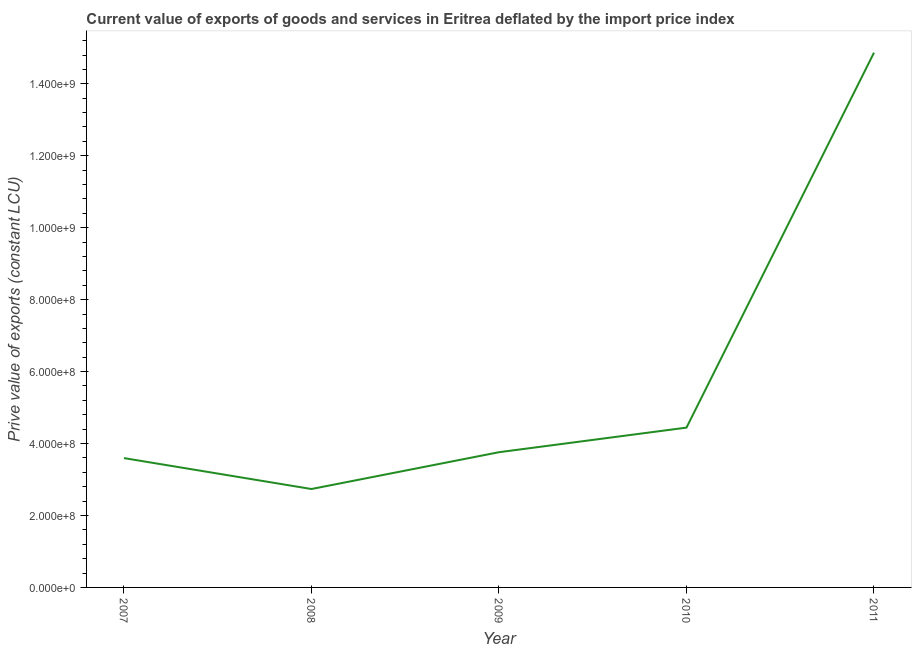What is the price value of exports in 2010?
Offer a terse response. 4.44e+08. Across all years, what is the maximum price value of exports?
Offer a terse response. 1.49e+09. Across all years, what is the minimum price value of exports?
Your answer should be very brief. 2.74e+08. What is the sum of the price value of exports?
Ensure brevity in your answer.  2.94e+09. What is the difference between the price value of exports in 2007 and 2008?
Give a very brief answer. 8.60e+07. What is the average price value of exports per year?
Your response must be concise. 5.88e+08. What is the median price value of exports?
Offer a very short reply. 3.76e+08. What is the ratio of the price value of exports in 2007 to that in 2010?
Provide a succinct answer. 0.81. Is the difference between the price value of exports in 2007 and 2008 greater than the difference between any two years?
Your answer should be compact. No. What is the difference between the highest and the second highest price value of exports?
Give a very brief answer. 1.04e+09. What is the difference between the highest and the lowest price value of exports?
Make the answer very short. 1.21e+09. In how many years, is the price value of exports greater than the average price value of exports taken over all years?
Keep it short and to the point. 1. How many lines are there?
Provide a short and direct response. 1. Are the values on the major ticks of Y-axis written in scientific E-notation?
Provide a short and direct response. Yes. Does the graph contain any zero values?
Offer a very short reply. No. What is the title of the graph?
Offer a very short reply. Current value of exports of goods and services in Eritrea deflated by the import price index. What is the label or title of the X-axis?
Offer a very short reply. Year. What is the label or title of the Y-axis?
Provide a short and direct response. Prive value of exports (constant LCU). What is the Prive value of exports (constant LCU) in 2007?
Offer a terse response. 3.60e+08. What is the Prive value of exports (constant LCU) of 2008?
Offer a very short reply. 2.74e+08. What is the Prive value of exports (constant LCU) in 2009?
Make the answer very short. 3.76e+08. What is the Prive value of exports (constant LCU) of 2010?
Give a very brief answer. 4.44e+08. What is the Prive value of exports (constant LCU) of 2011?
Make the answer very short. 1.49e+09. What is the difference between the Prive value of exports (constant LCU) in 2007 and 2008?
Provide a short and direct response. 8.60e+07. What is the difference between the Prive value of exports (constant LCU) in 2007 and 2009?
Ensure brevity in your answer.  -1.63e+07. What is the difference between the Prive value of exports (constant LCU) in 2007 and 2010?
Provide a succinct answer. -8.47e+07. What is the difference between the Prive value of exports (constant LCU) in 2007 and 2011?
Give a very brief answer. -1.13e+09. What is the difference between the Prive value of exports (constant LCU) in 2008 and 2009?
Keep it short and to the point. -1.02e+08. What is the difference between the Prive value of exports (constant LCU) in 2008 and 2010?
Your answer should be compact. -1.71e+08. What is the difference between the Prive value of exports (constant LCU) in 2008 and 2011?
Keep it short and to the point. -1.21e+09. What is the difference between the Prive value of exports (constant LCU) in 2009 and 2010?
Provide a short and direct response. -6.84e+07. What is the difference between the Prive value of exports (constant LCU) in 2009 and 2011?
Ensure brevity in your answer.  -1.11e+09. What is the difference between the Prive value of exports (constant LCU) in 2010 and 2011?
Make the answer very short. -1.04e+09. What is the ratio of the Prive value of exports (constant LCU) in 2007 to that in 2008?
Your answer should be compact. 1.31. What is the ratio of the Prive value of exports (constant LCU) in 2007 to that in 2010?
Offer a terse response. 0.81. What is the ratio of the Prive value of exports (constant LCU) in 2007 to that in 2011?
Offer a very short reply. 0.24. What is the ratio of the Prive value of exports (constant LCU) in 2008 to that in 2009?
Offer a terse response. 0.73. What is the ratio of the Prive value of exports (constant LCU) in 2008 to that in 2010?
Provide a short and direct response. 0.62. What is the ratio of the Prive value of exports (constant LCU) in 2008 to that in 2011?
Make the answer very short. 0.18. What is the ratio of the Prive value of exports (constant LCU) in 2009 to that in 2010?
Your response must be concise. 0.85. What is the ratio of the Prive value of exports (constant LCU) in 2009 to that in 2011?
Your answer should be compact. 0.25. What is the ratio of the Prive value of exports (constant LCU) in 2010 to that in 2011?
Keep it short and to the point. 0.3. 